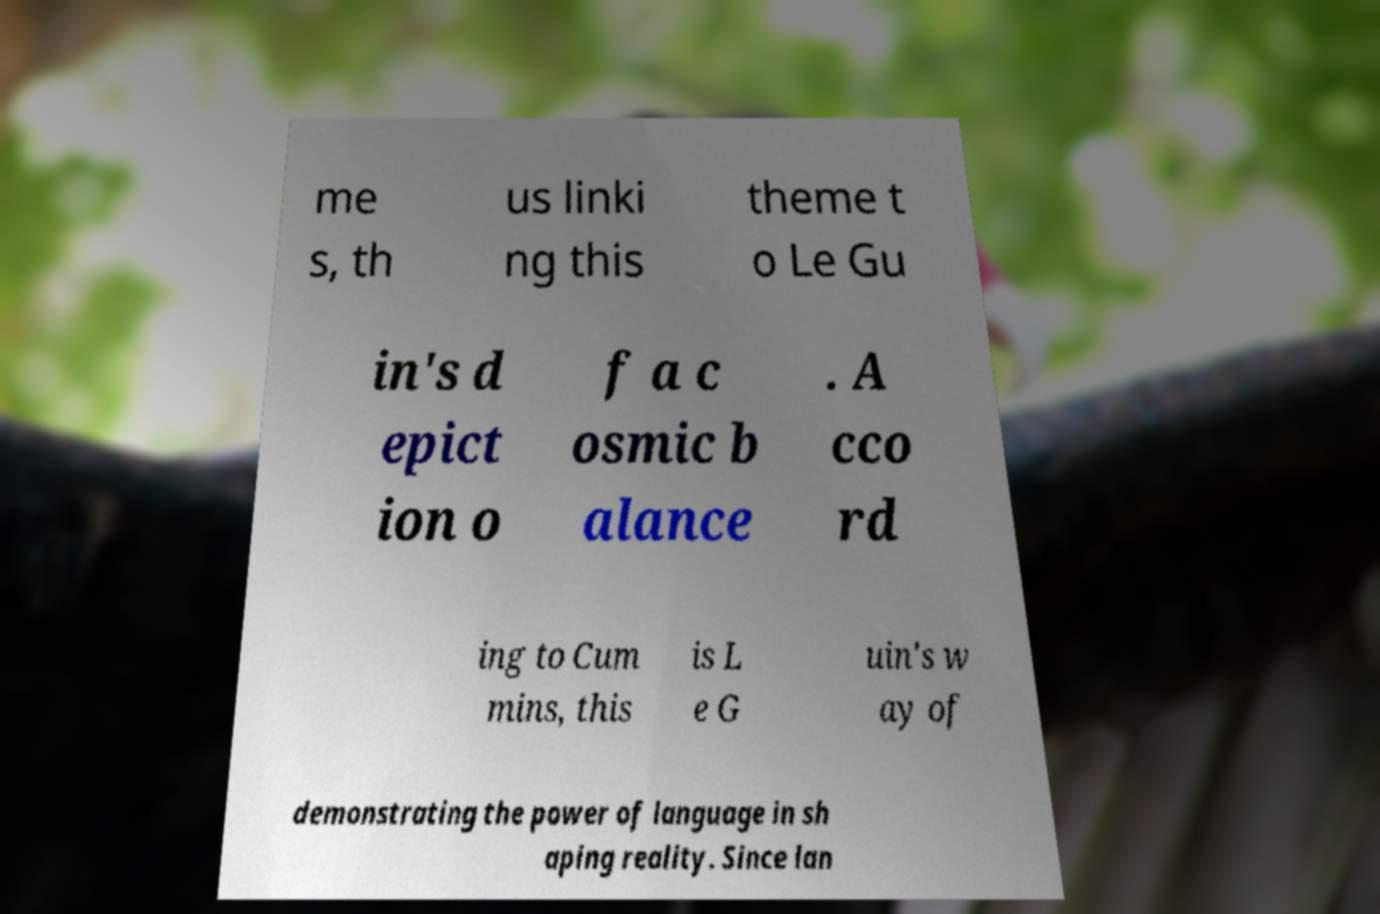Can you accurately transcribe the text from the provided image for me? me s, th us linki ng this theme t o Le Gu in's d epict ion o f a c osmic b alance . A cco rd ing to Cum mins, this is L e G uin's w ay of demonstrating the power of language in sh aping reality. Since lan 